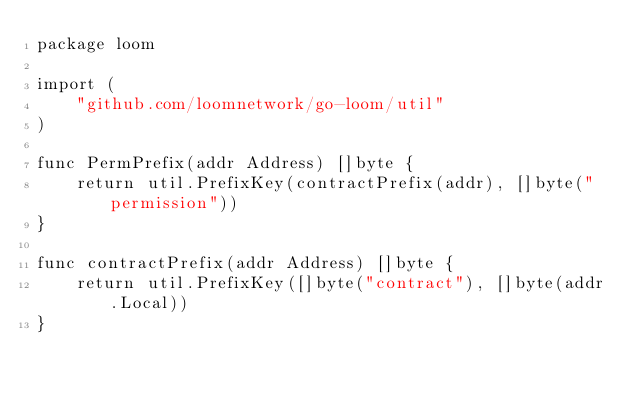Convert code to text. <code><loc_0><loc_0><loc_500><loc_500><_Go_>package loom

import (
	"github.com/loomnetwork/go-loom/util"
)

func PermPrefix(addr Address) []byte {
	return util.PrefixKey(contractPrefix(addr), []byte("permission"))
}

func contractPrefix(addr Address) []byte {
	return util.PrefixKey([]byte("contract"), []byte(addr.Local))
}
</code> 